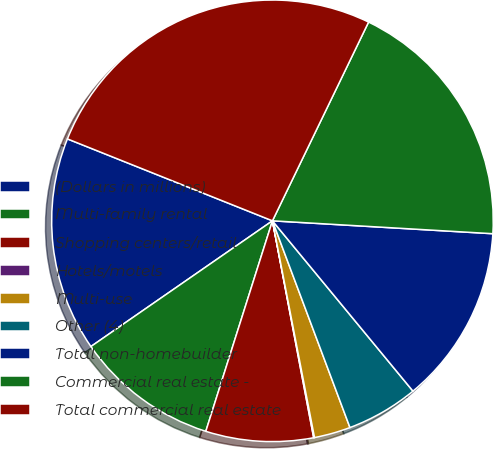<chart> <loc_0><loc_0><loc_500><loc_500><pie_chart><fcel>(Dollars in millions)<fcel>Multi-family rental<fcel>Shopping centers/retail<fcel>Hotels/motels<fcel>Multi-use<fcel>Other (4)<fcel>Total non-homebuilder<fcel>Commercial real estate -<fcel>Total commercial real estate<nl><fcel>15.69%<fcel>10.48%<fcel>7.87%<fcel>0.06%<fcel>2.66%<fcel>5.27%<fcel>13.09%<fcel>18.76%<fcel>26.12%<nl></chart> 